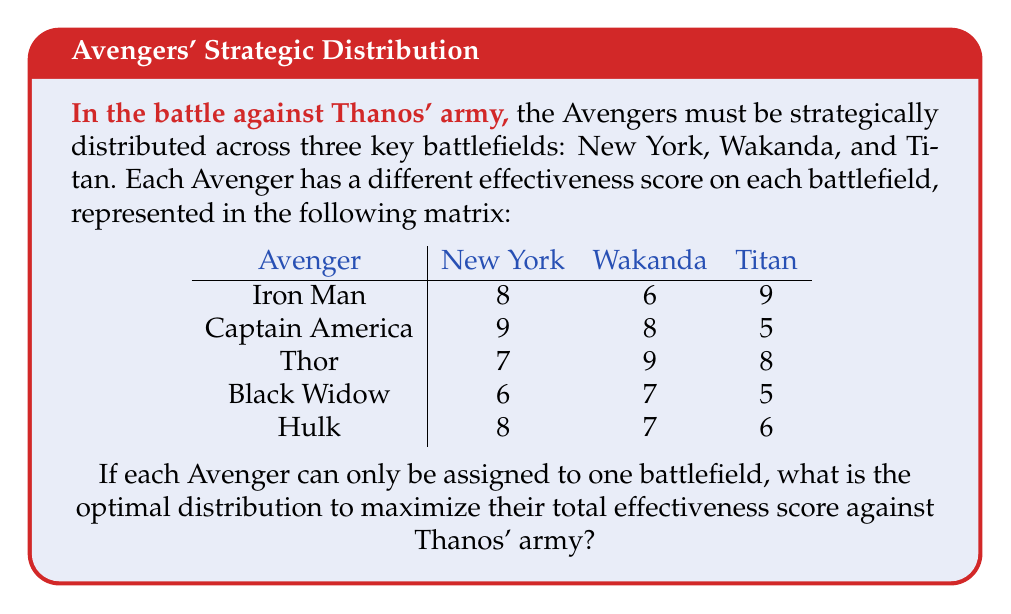Show me your answer to this math problem. To solve this problem, we'll use the Hungarian algorithm, which is an optimization method for assignment problems. Here's the step-by-step solution:

1) First, we need to convert this maximization problem into a minimization problem. We do this by subtracting each element from the maximum value in the matrix (9):

$$
\begin{array}{c|ccc}
\text{Avenger} & \text{New York} & \text{Wakanda} & \text{Titan} \\
\hline
\text{Iron Man} & 1 & 3 & 0 \\
\text{Captain America} & 0 & 1 & 4 \\
\text{Thor} & 2 & 0 & 1 \\
\text{Black Widow} & 3 & 2 & 4 \\
\text{Hulk} & 1 & 2 & 3 \\
\end{array}
$$

2) Now we apply the Hungarian algorithm:

   a) Subtract the smallest element in each row from all elements in that row:

   $$
   \begin{array}{c|ccc}
   \text{Avenger} & \text{New York} & \text{Wakanda} & \text{Titan} \\
   \hline
   \text{Iron Man} & 1 & 3 & 0 \\
   \text{Captain America} & 0 & 1 & 4 \\
   \text{Thor} & 2 & 0 & 1 \\
   \text{Black Widow} & 1 & 0 & 2 \\
   \text{Hulk} & 0 & 1 & 2 \\
   \end{array}
   $$

   b) Subtract the smallest element in each column from all elements in that column:

   $$
   \begin{array}{c|ccc}
   \text{Avenger} & \text{New York} & \text{Wakanda} & \text{Titan} \\
   \hline
   \text{Iron Man} & 1 & 3 & 0 \\
   \text{Captain America} & 0 & 1 & 4 \\
   \text{Thor} & 2 & 0 & 1 \\
   \text{Black Widow} & 1 & 0 & 2 \\
   \text{Hulk} & 0 & 1 & 2 \\
   \end{array}
   $$

3) Now we try to find an optimal assignment. We can assign:
   - Captain America to New York
   - Thor to Wakanda
   - Iron Man to Titan

4) We still need to assign Black Widow and Hulk. We can't do this optimally yet, so we need to iterate:

   a) Cover all zeros with the minimum number of lines:

   $$
   \begin{array}{c|ccc}
   \text{Avenger} & \text{New York} & \text{Wakanda} & \text{Titan} \\
   \hline
   \text{Iron Man} & 1 & 3 & \color{red}0 \\
   \text{Captain America} & \color{red}0 & 1 & 4 \\
   \text{Thor} & 2 & \color{red}0 & 1 \\
   \text{Black Widow} & 1 & \color{red}0 & 2 \\
   \text{Hulk} & \color{red}0 & 1 & 2 \\
   \end{array}
   $$

   b) Find the smallest uncovered element (1), subtract it from all uncovered elements and add it to elements at the intersection of cover lines:

   $$
   \begin{array}{c|ccc}
   \text{Avenger} & \text{New York} & \text{Wakanda} & \text{Titan} \\
   \hline
   \text{Iron Man} & 0 & 2 & 0 \\
   \text{Captain America} & 0 & 1 & 3 \\
   \text{Thor} & 1 & 0 & 0 \\
   \text{Black Widow} & 0 & 0 & 1 \\
   \text{Hulk} & 0 & 1 & 1 \\
   \end{array}
   $$

5) Now we can make an optimal assignment:
   - Iron Man to Titan (9)
   - Captain America to New York (9)
   - Thor to Wakanda (9)
   - Black Widow to Wakanda (7)
   - Hulk to New York (8)

6) The total effectiveness score is 9 + 9 + 9 + 7 + 8 = 42.
Answer: Iron Man: Titan, Captain America: New York, Thor: Wakanda, Black Widow: Wakanda, Hulk: New York. Total score: 42. 